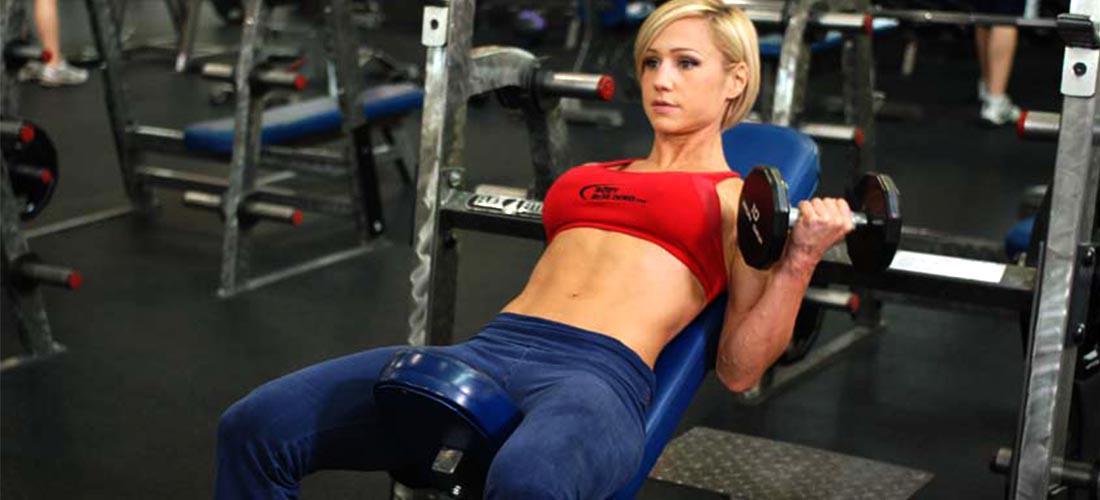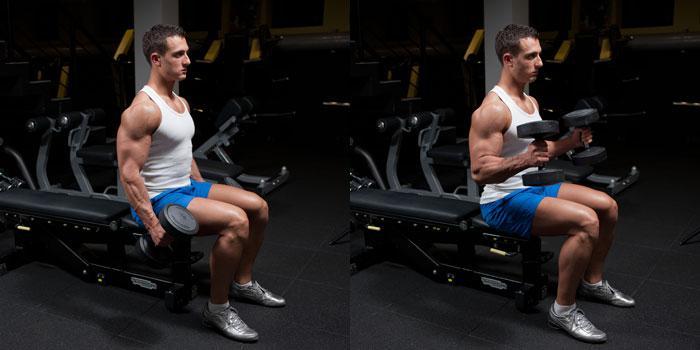The first image is the image on the left, the second image is the image on the right. For the images displayed, is the sentence "At least one woman is featured." factually correct? Answer yes or no. Yes. 